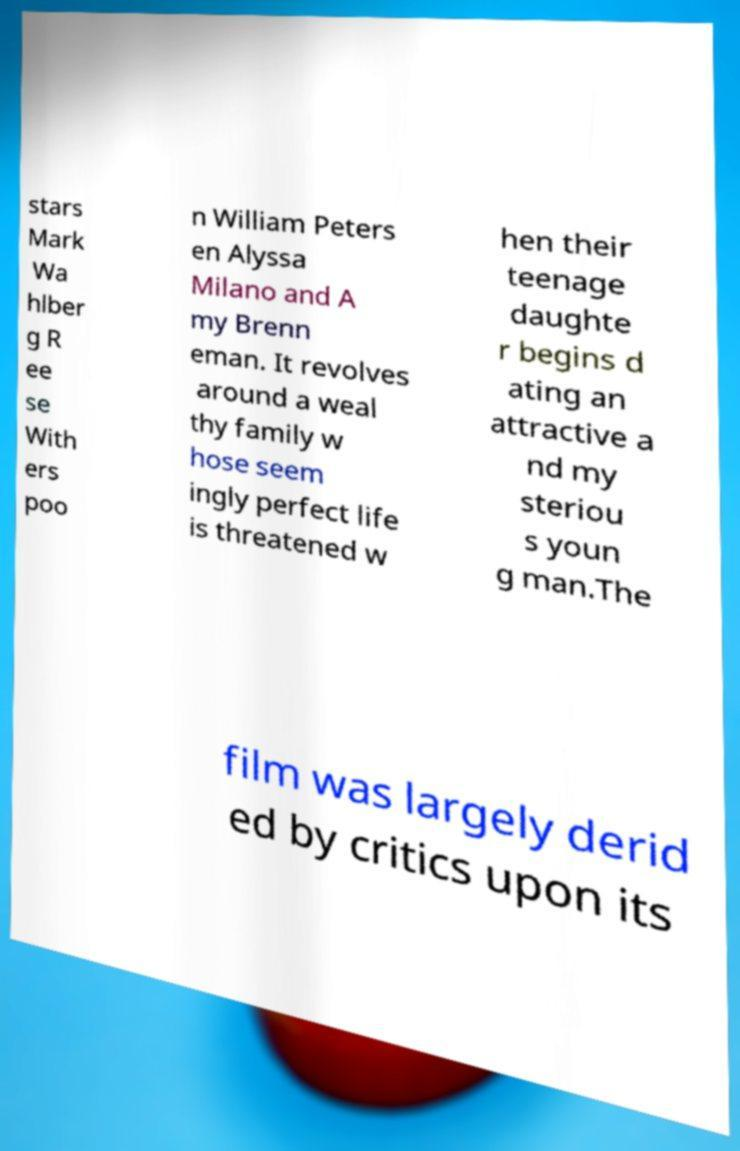Please read and relay the text visible in this image. What does it say? stars Mark Wa hlber g R ee se With ers poo n William Peters en Alyssa Milano and A my Brenn eman. It revolves around a weal thy family w hose seem ingly perfect life is threatened w hen their teenage daughte r begins d ating an attractive a nd my steriou s youn g man.The film was largely derid ed by critics upon its 